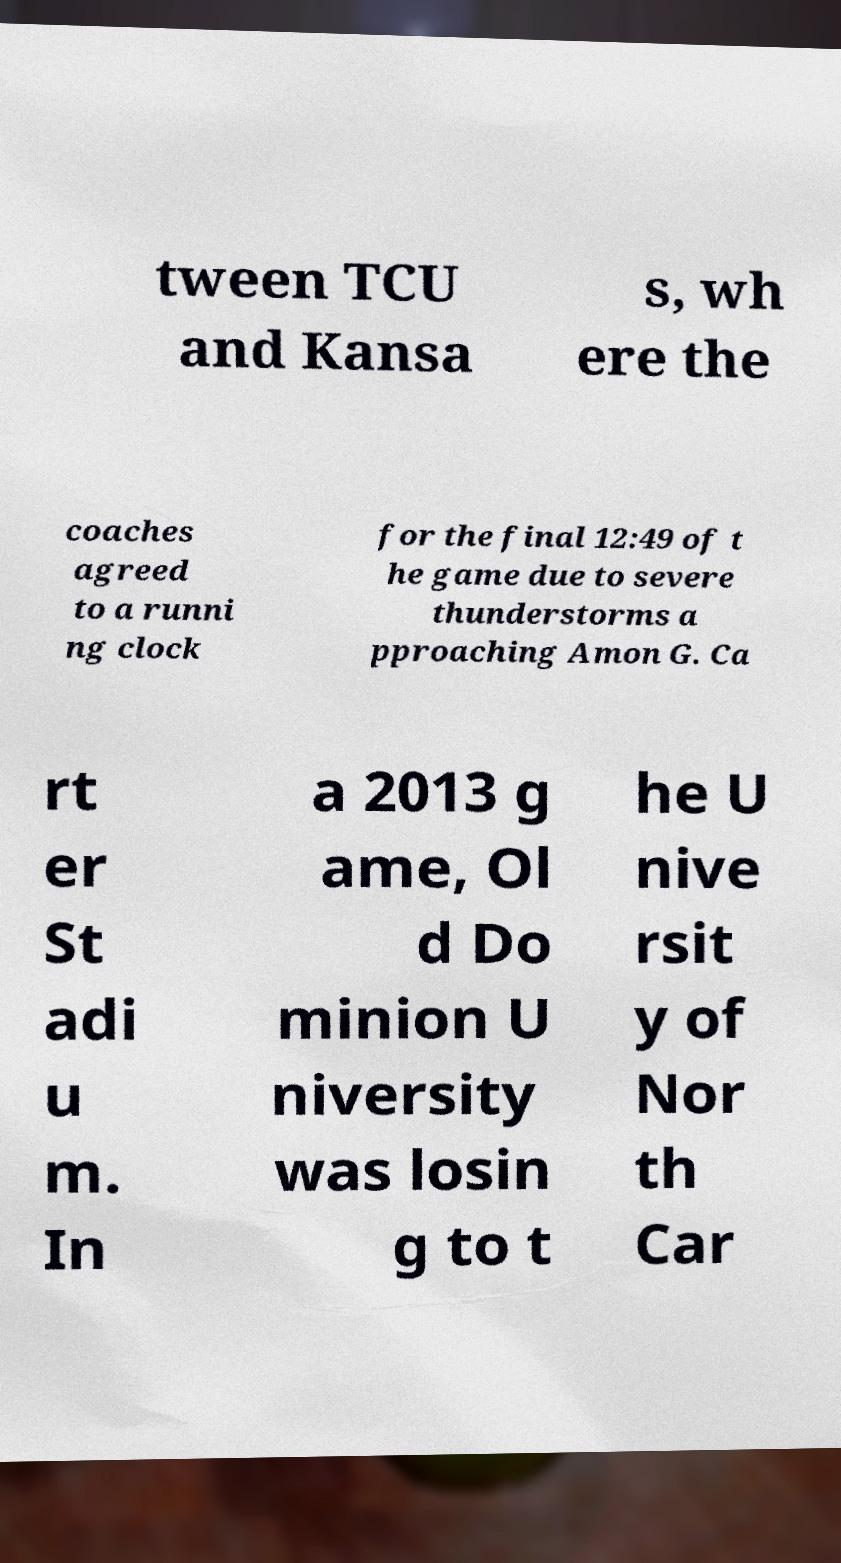Please identify and transcribe the text found in this image. tween TCU and Kansa s, wh ere the coaches agreed to a runni ng clock for the final 12:49 of t he game due to severe thunderstorms a pproaching Amon G. Ca rt er St adi u m. In a 2013 g ame, Ol d Do minion U niversity was losin g to t he U nive rsit y of Nor th Car 